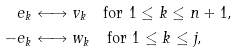<formula> <loc_0><loc_0><loc_500><loc_500>e _ { k } & \longleftrightarrow v _ { k } \quad \text {for $1\leq k\leq n+1$,} \\ - e _ { k } & \longleftrightarrow w _ { k } \quad \text {for $1\leq k\leq j$,}</formula> 